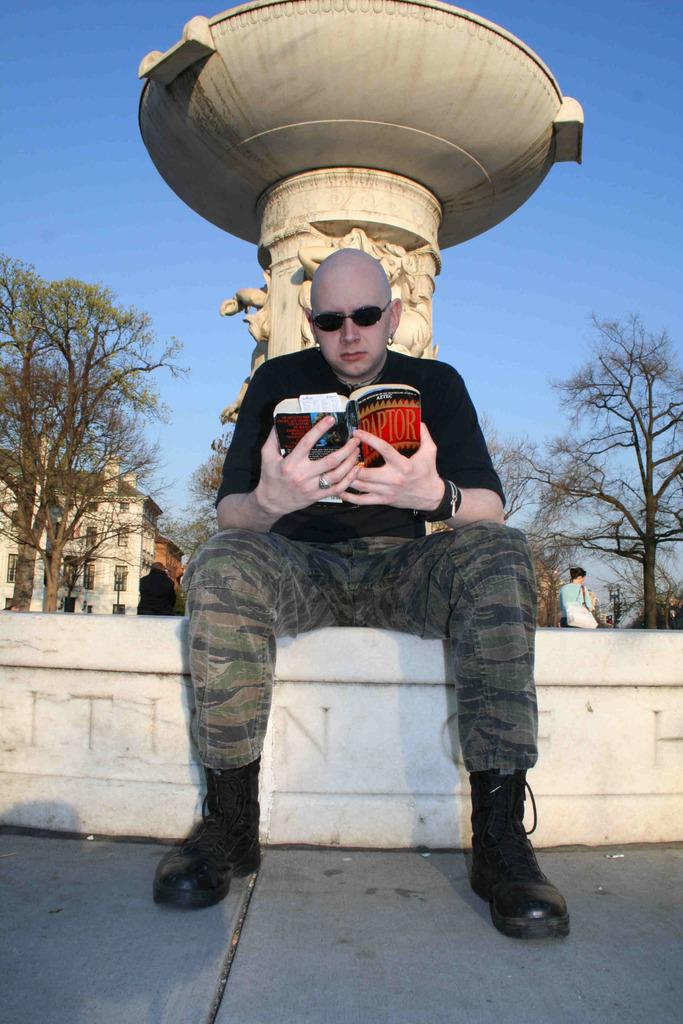What is the main subject of the image? There is a man in the image. What is the man doing in the image? The man is sitting on a wall. What is the man wearing in the image? The man is wearing a black T-shirt. What can be seen in the background of the image? There is a fountain, trees, a building, and the sky visible in the background of the image. What type of cup is the man holding in the image? There is no cup present in the image; the man is sitting on a wall and wearing a black T-shirt. 